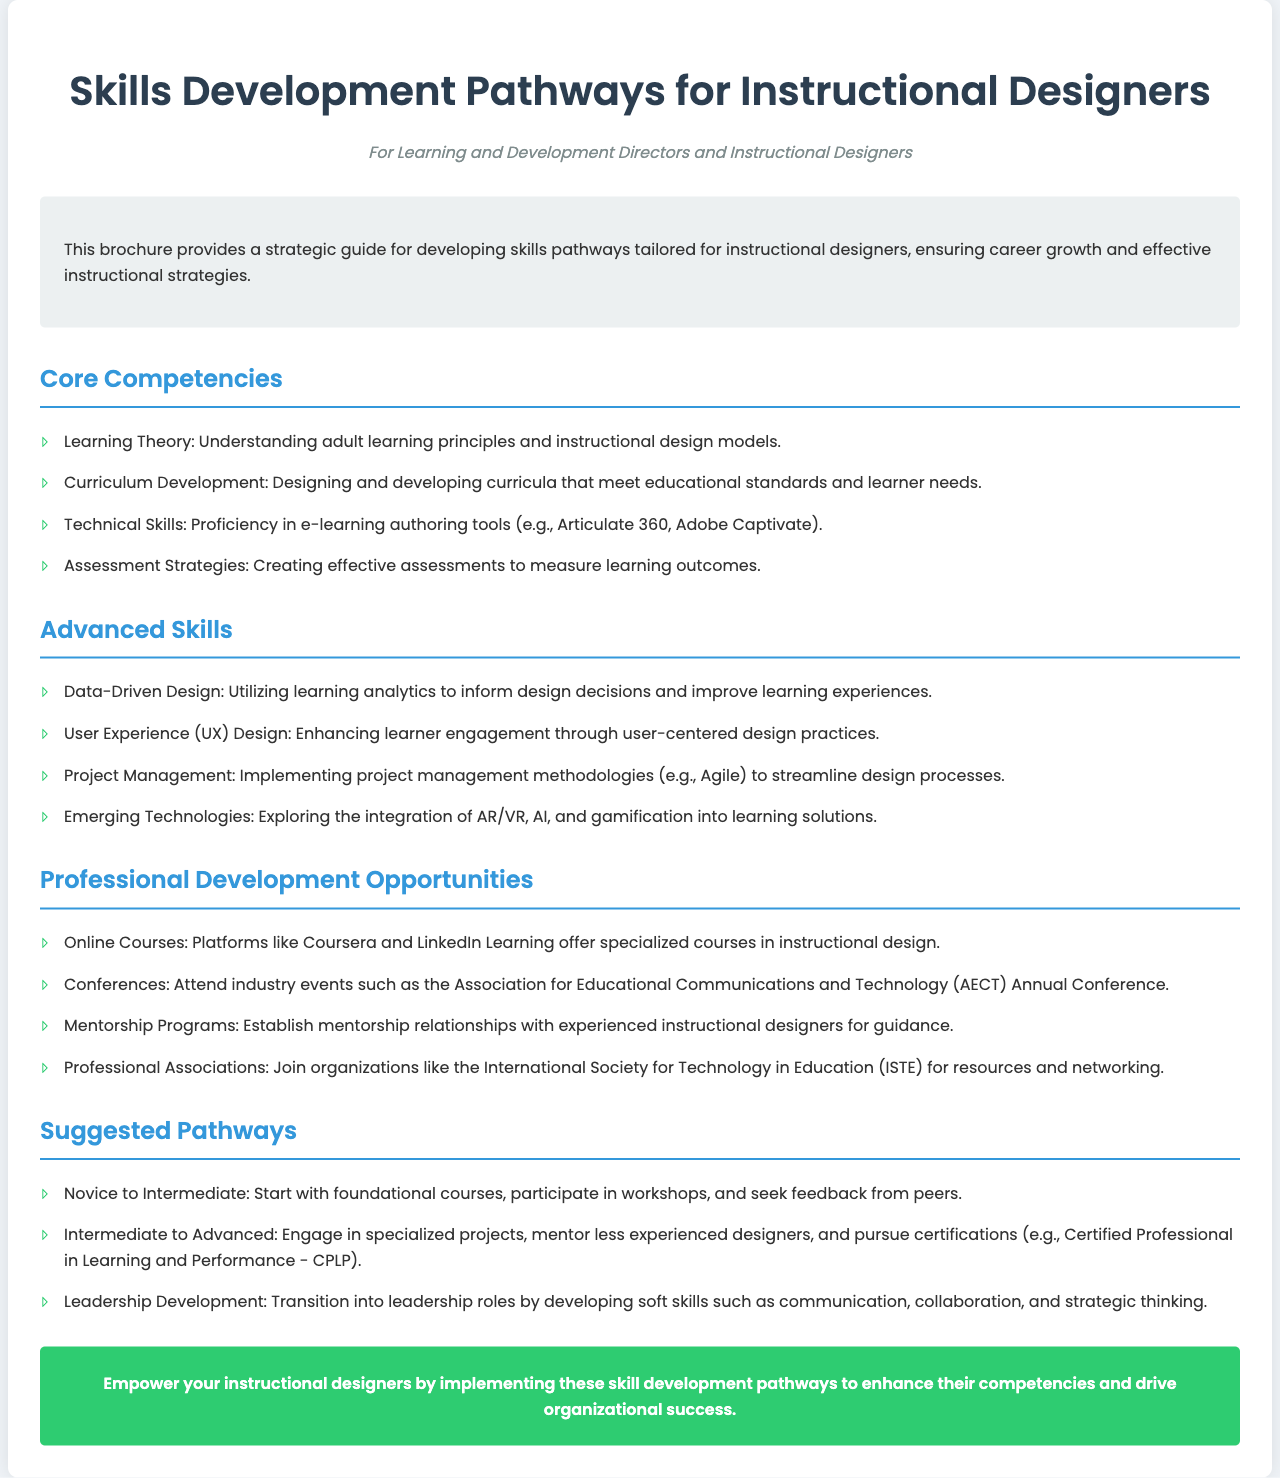What is the target audience of the brochure? The target audience is specified in the header area of the document, which mentions "Learning and Development Directors and Instructional Designers."
Answer: Learning and Development Directors and Instructional Designers How many core competencies are listed? The number of core competencies can be determined by counting the items in the "Core Competencies" section of the document. There are four listed.
Answer: 4 What is the first suggested pathway for novice instructional designers? The first suggested pathway is detailed in the "Suggested Pathways" section, which states, "Start with foundational courses, participate in workshops, and seek feedback from peers."
Answer: Start with foundational courses Which skill is emphasized for advanced instructional designers? The "Advanced Skills" section highlights several skills, and one specifically is "Data-Driven Design."
Answer: Data-Driven Design What type of organizations are mentioned for networking opportunities? The "Professional Associations" item in the "Professional Development Opportunities" section mentions organizations like the International Society for Technology in Education (ISTE) for resources and networking.
Answer: International Society for Technology in Education (ISTE) How many advanced skills are outlined in the document? The total number of advanced skills can be found by counting the items listed under the "Advanced Skills" section, which currently lists four skills.
Answer: 4 